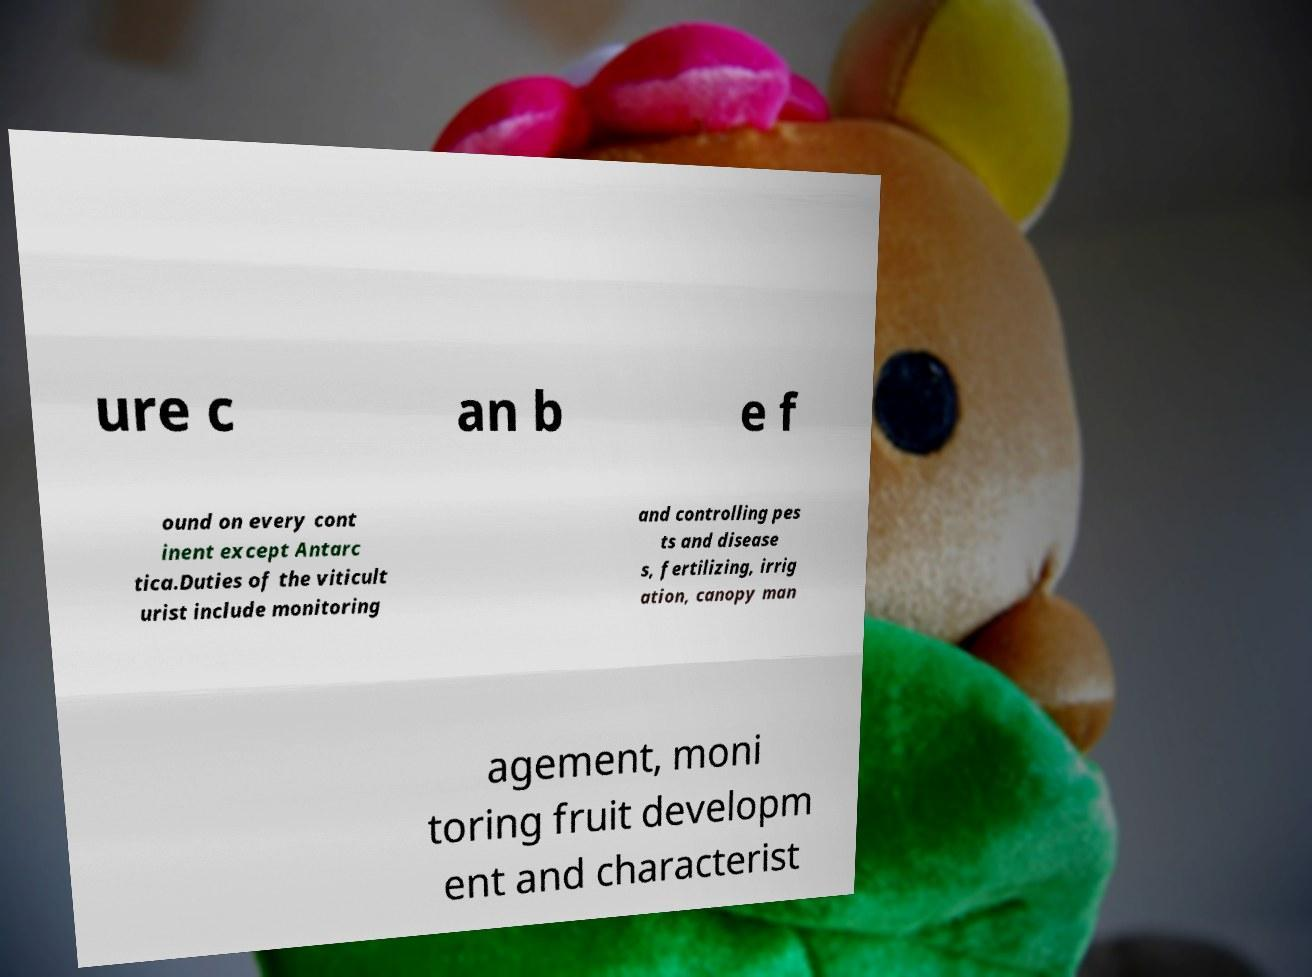There's text embedded in this image that I need extracted. Can you transcribe it verbatim? ure c an b e f ound on every cont inent except Antarc tica.Duties of the viticult urist include monitoring and controlling pes ts and disease s, fertilizing, irrig ation, canopy man agement, moni toring fruit developm ent and characterist 